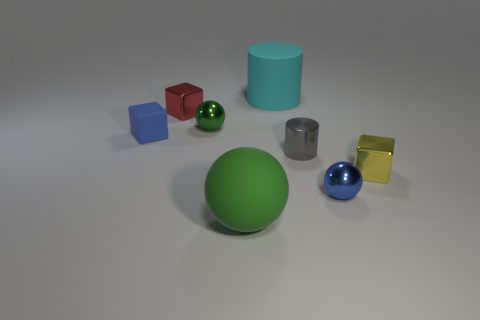Subtract all green blocks. Subtract all gray spheres. How many blocks are left? 3 Subtract all blue blocks. How many gray cylinders are left? 1 Add 1 tiny blues. How many cyans exist? 0 Subtract all blue matte cubes. Subtract all gray spheres. How many objects are left? 7 Add 5 green spheres. How many green spheres are left? 7 Add 6 small blue matte things. How many small blue matte things exist? 7 Add 2 gray shiny cylinders. How many objects exist? 10 Subtract all green spheres. How many spheres are left? 1 Subtract all rubber blocks. How many blocks are left? 2 Subtract 0 cyan balls. How many objects are left? 8 